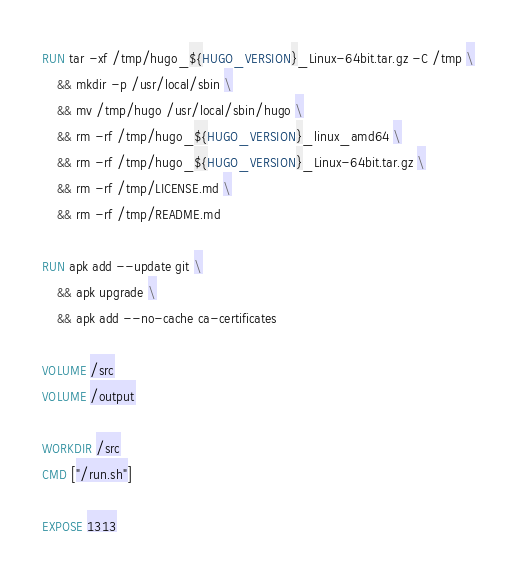<code> <loc_0><loc_0><loc_500><loc_500><_Dockerfile_>RUN tar -xf /tmp/hugo_${HUGO_VERSION}_Linux-64bit.tar.gz -C /tmp \
    && mkdir -p /usr/local/sbin \
    && mv /tmp/hugo /usr/local/sbin/hugo \
    && rm -rf /tmp/hugo_${HUGO_VERSION}_linux_amd64 \
    && rm -rf /tmp/hugo_${HUGO_VERSION}_Linux-64bit.tar.gz \
    && rm -rf /tmp/LICENSE.md \
    && rm -rf /tmp/README.md

RUN apk add --update git \
    && apk upgrade \
    && apk add --no-cache ca-certificates

VOLUME /src
VOLUME /output

WORKDIR /src
CMD ["/run.sh"]

EXPOSE 1313
</code> 